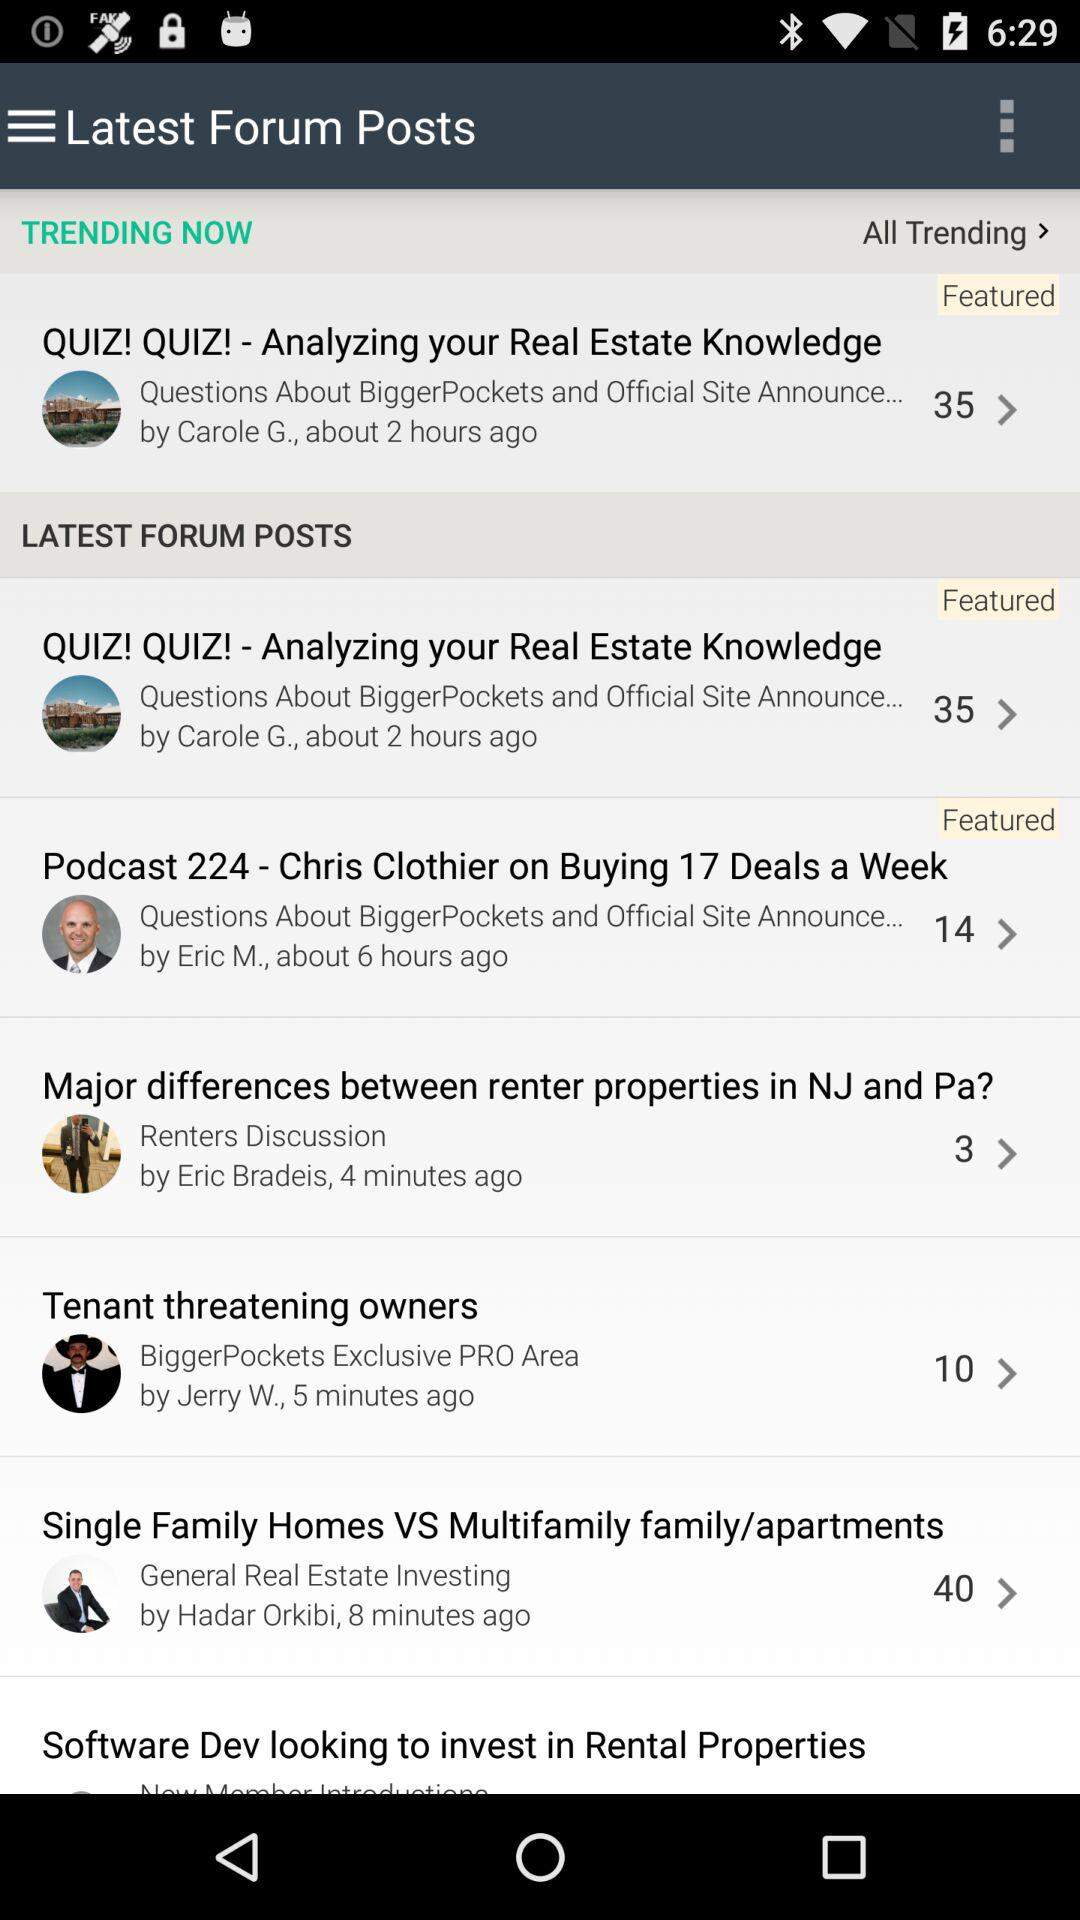How many minutes ago was the post "Tenant threatening owners" posted? The post was posted 5 minutes ago. 